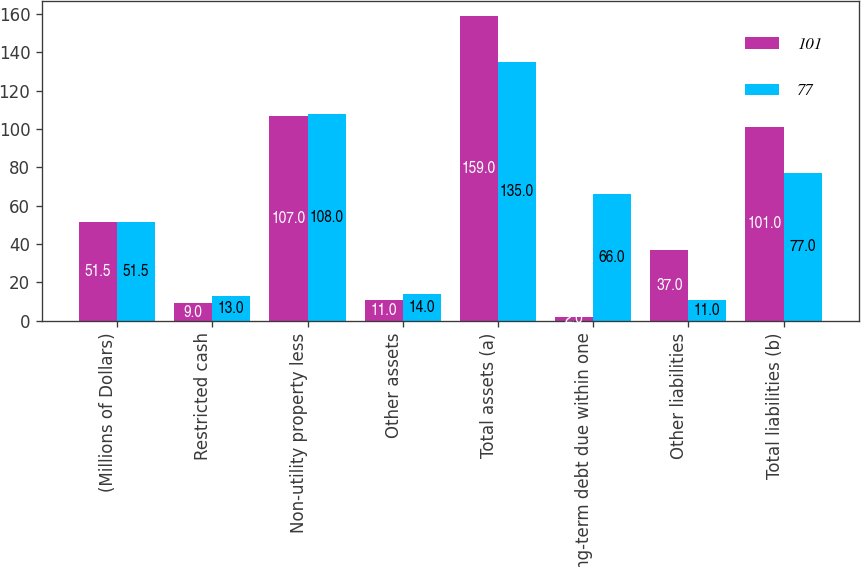Convert chart to OTSL. <chart><loc_0><loc_0><loc_500><loc_500><stacked_bar_chart><ecel><fcel>(Millions of Dollars)<fcel>Restricted cash<fcel>Non-utility property less<fcel>Other assets<fcel>Total assets (a)<fcel>Long-term debt due within one<fcel>Other liabilities<fcel>Total liabilities (b)<nl><fcel>101<fcel>51.5<fcel>9<fcel>107<fcel>11<fcel>159<fcel>2<fcel>37<fcel>101<nl><fcel>77<fcel>51.5<fcel>13<fcel>108<fcel>14<fcel>135<fcel>66<fcel>11<fcel>77<nl></chart> 